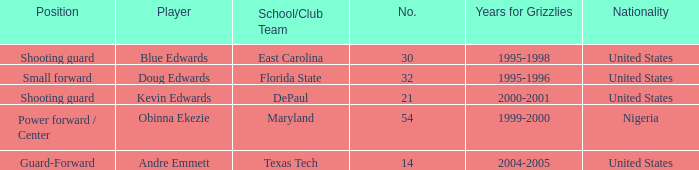When was the school/club team for grizzles was maryland 1999-2000. 